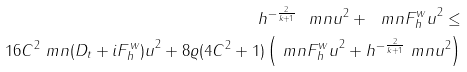Convert formula to latex. <formula><loc_0><loc_0><loc_500><loc_500>h ^ { - \frac { 2 } { k + 1 } } \ m n { u } ^ { 2 } + \ m n { F ^ { w } _ { h } u } ^ { 2 } \leq \\ 1 6 C ^ { 2 } \ m n { ( D _ { t } + i F _ { h } ^ { w } ) u } ^ { 2 } + 8 { \varrho } ( 4 C ^ { 2 } + 1 ) \left ( \ m n { F _ { h } ^ { w } u } ^ { 2 } + h ^ { - \frac { 2 } { k + 1 } } \ m n { u } ^ { 2 } \right )</formula> 